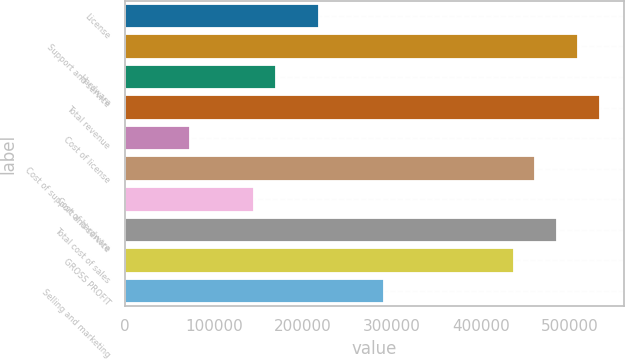<chart> <loc_0><loc_0><loc_500><loc_500><bar_chart><fcel>License<fcel>Support and service<fcel>Hardware<fcel>Total revenue<fcel>Cost of license<fcel>Cost of support and service<fcel>Cost of hardware<fcel>Total cost of sales<fcel>GROSS PROFIT<fcel>Selling and marketing<nl><fcel>218372<fcel>509533<fcel>169845<fcel>533797<fcel>72790.8<fcel>461006<fcel>145581<fcel>485270<fcel>436743<fcel>291162<nl></chart> 